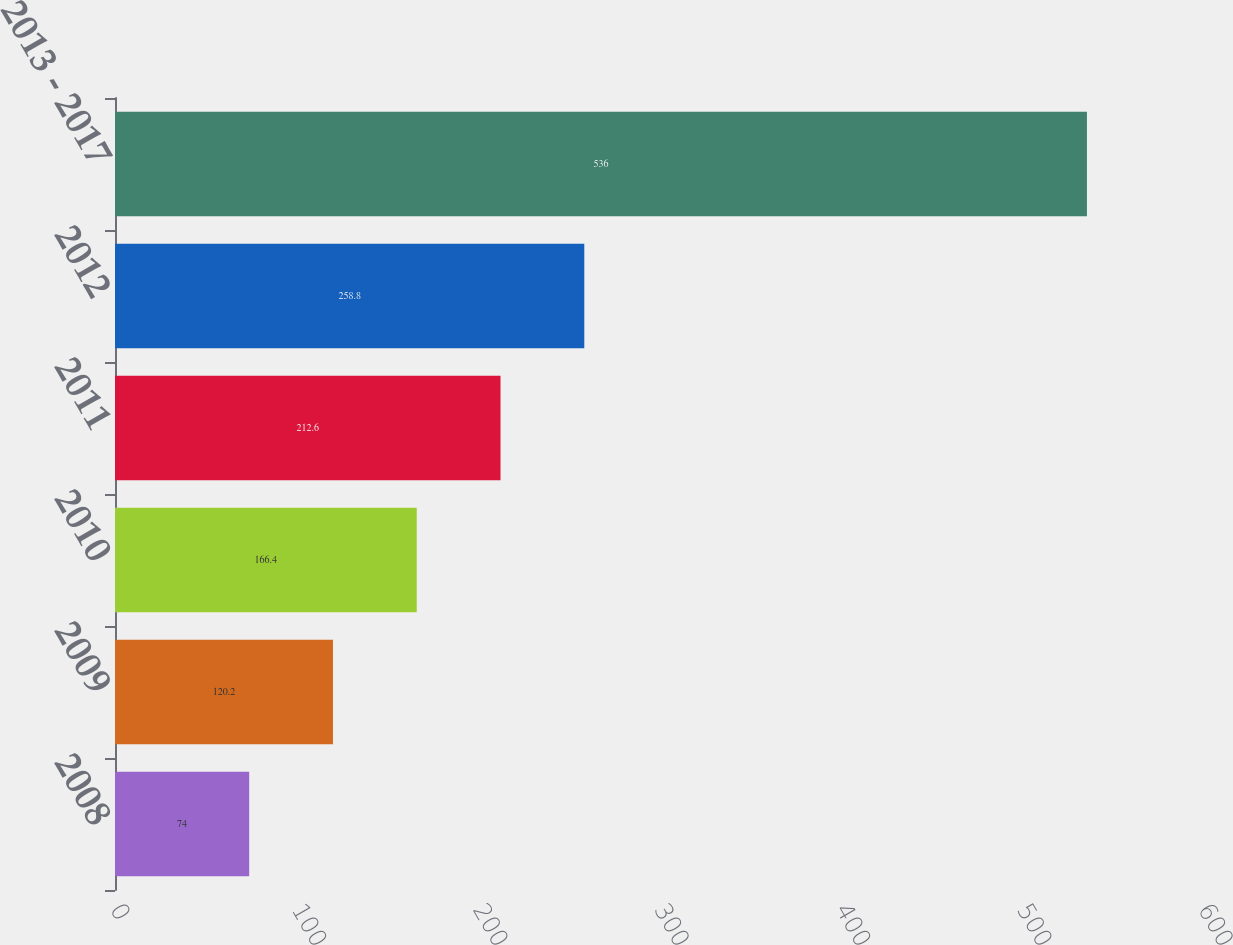<chart> <loc_0><loc_0><loc_500><loc_500><bar_chart><fcel>2008<fcel>2009<fcel>2010<fcel>2011<fcel>2012<fcel>2013 - 2017<nl><fcel>74<fcel>120.2<fcel>166.4<fcel>212.6<fcel>258.8<fcel>536<nl></chart> 